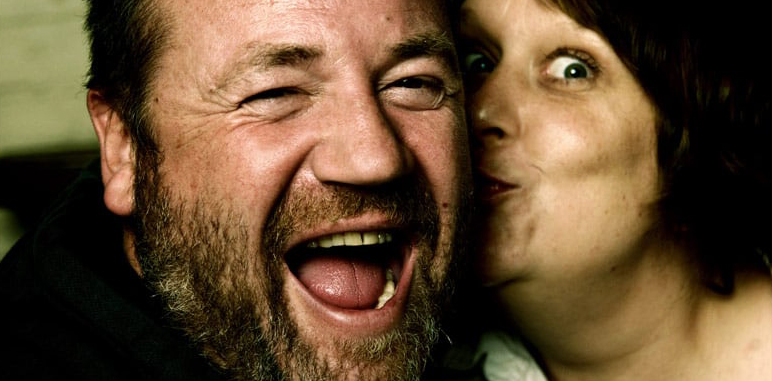What might have caused this joyful reaction? While the exact cause isn't visible, the interaction with the woman, who is playfully kissing his cheek, might suggest a personal joke or a shared humorous moment between the two. The spontaneity of the kiss also appears to contribute to the man's joyful reaction. 